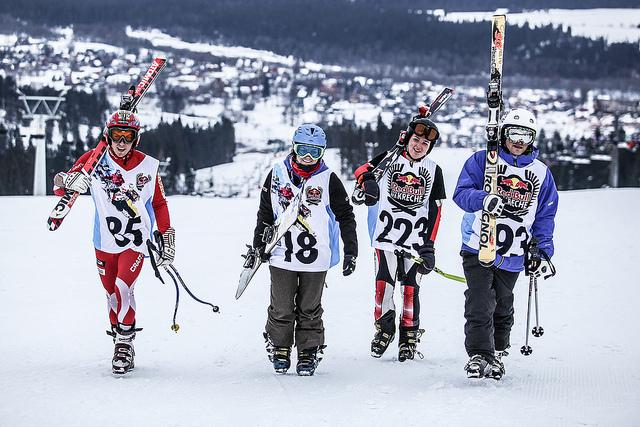How many of the 4 kids are holding skies?

Choices:
A) 1/4
B) 4/4
C) 2/4
D) 3/4 3/4 